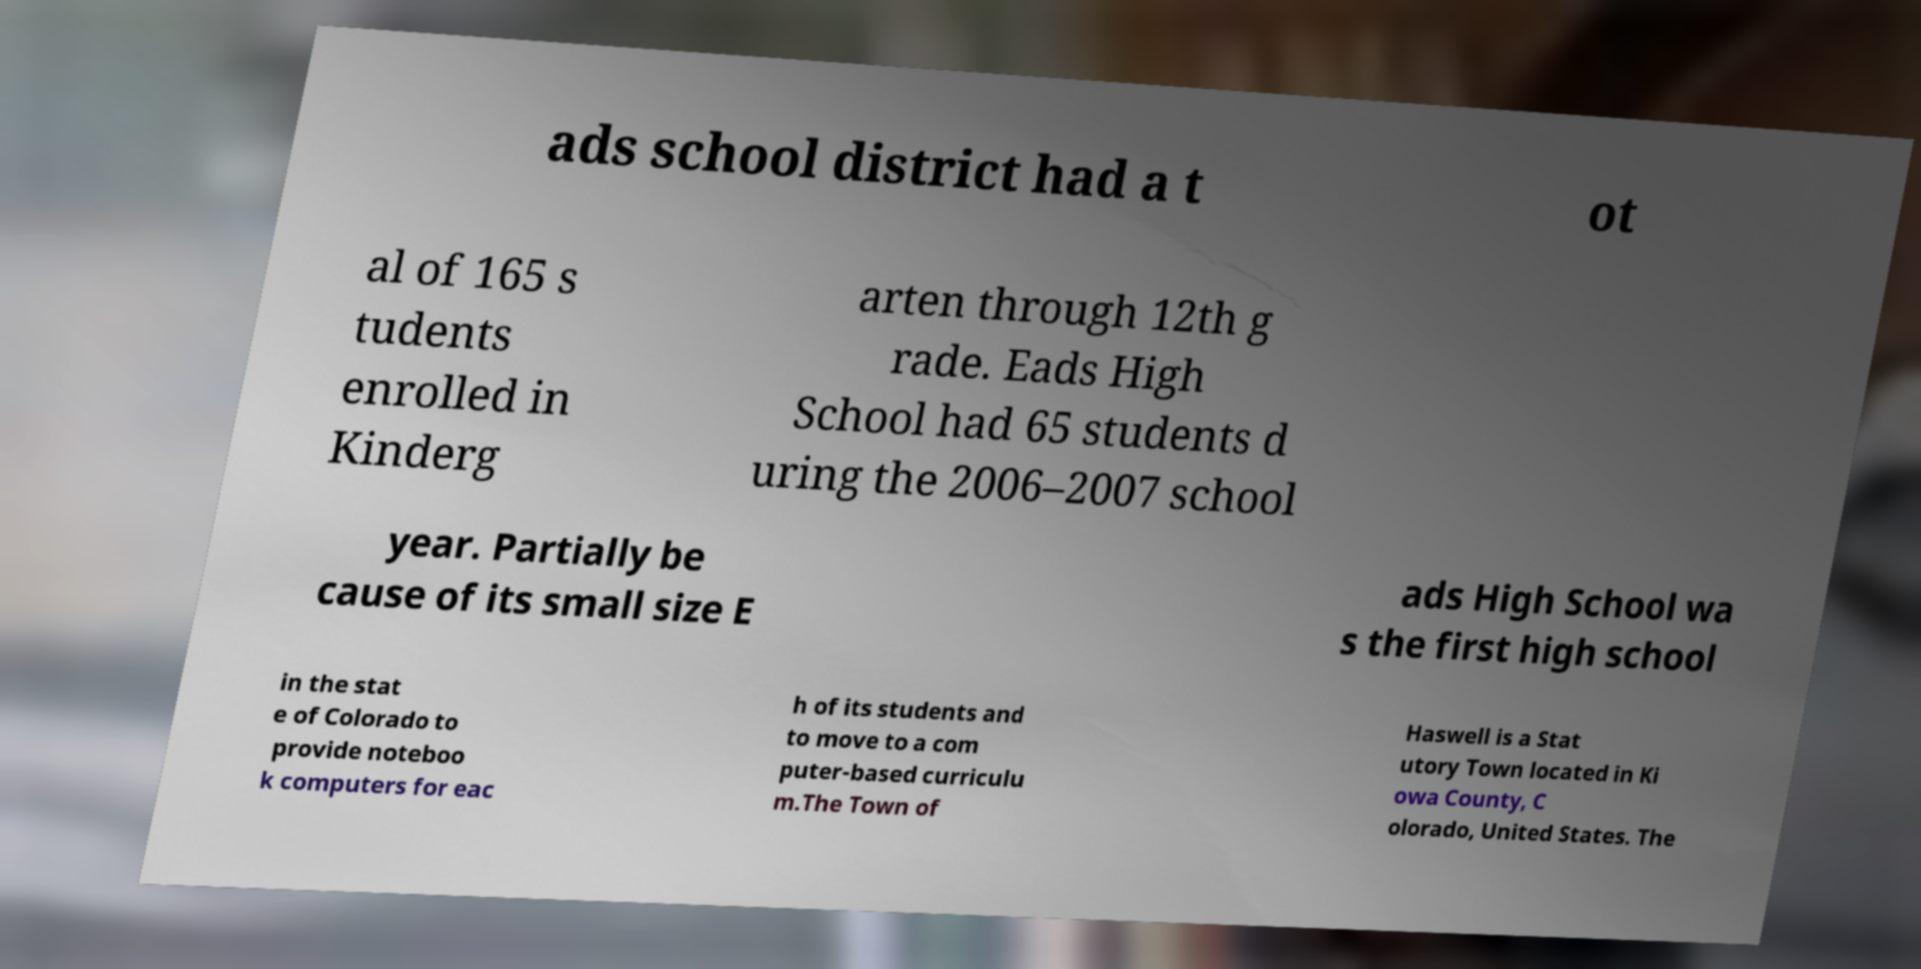There's text embedded in this image that I need extracted. Can you transcribe it verbatim? ads school district had a t ot al of 165 s tudents enrolled in Kinderg arten through 12th g rade. Eads High School had 65 students d uring the 2006–2007 school year. Partially be cause of its small size E ads High School wa s the first high school in the stat e of Colorado to provide noteboo k computers for eac h of its students and to move to a com puter-based curriculu m.The Town of Haswell is a Stat utory Town located in Ki owa County, C olorado, United States. The 